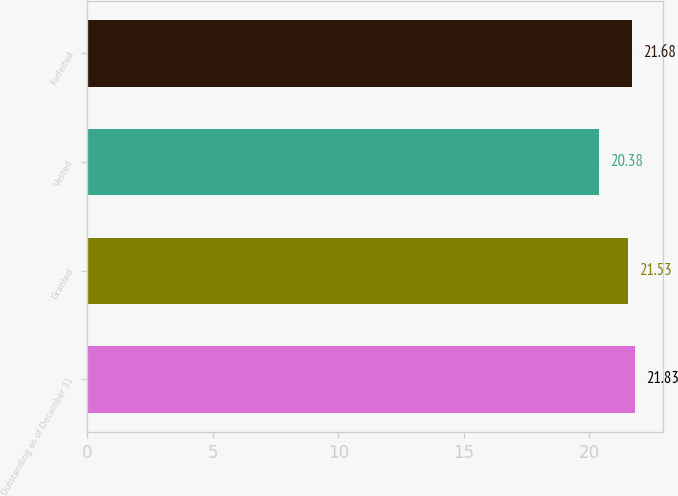<chart> <loc_0><loc_0><loc_500><loc_500><bar_chart><fcel>Outstanding as of December 31<fcel>Granted<fcel>Vested<fcel>Forfeited<nl><fcel>21.83<fcel>21.53<fcel>20.38<fcel>21.68<nl></chart> 